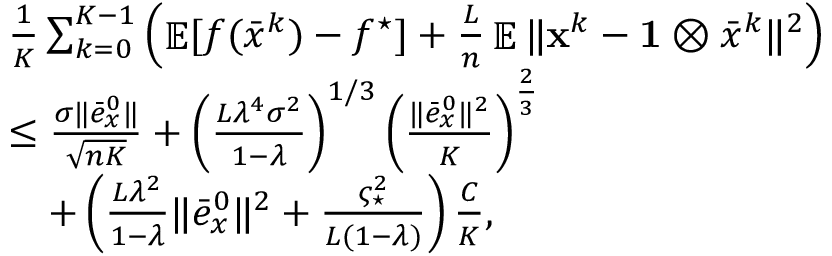<formula> <loc_0><loc_0><loc_500><loc_500>\begin{array} { r l } & { \frac { 1 } { K } \sum _ { k = 0 } ^ { K - 1 } \left ( \mathbb { E } [ f ( \bar { x } ^ { k } ) - f ^ { ^ { * } } ] + \frac { L } { n } \mathbb { E } \| { x } ^ { k } - 1 \otimes \bar { x } ^ { k } \| ^ { 2 } \right ) } \\ & { \leq \frac { \sigma \| \bar { e } _ { x } ^ { 0 } \| } { \sqrt { n K } } + \left ( \frac { L \lambda ^ { 4 } \sigma ^ { 2 } } { 1 - \lambda } \right ) ^ { 1 / 3 } \left ( \frac { \| \bar { e } _ { x } ^ { 0 } \| ^ { 2 } } { K } \right ) ^ { \frac { 2 } { 3 } } } \\ & { \quad + \left ( \frac { L \lambda ^ { 2 } } { 1 - \lambda } \| \bar { e } _ { x } ^ { 0 } \| ^ { 2 } + \frac { \varsigma _ { ^ { * } } ^ { 2 } } { L ( 1 - \lambda ) } \right ) \frac { C } { K } , } \end{array}</formula> 